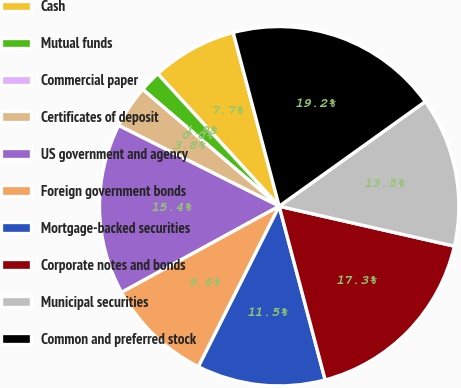Convert chart to OTSL. <chart><loc_0><loc_0><loc_500><loc_500><pie_chart><fcel>Cash<fcel>Mutual funds<fcel>Commercial paper<fcel>Certificates of deposit<fcel>US government and agency<fcel>Foreign government bonds<fcel>Mortgage-backed securities<fcel>Corporate notes and bonds<fcel>Municipal securities<fcel>Common and preferred stock<nl><fcel>7.69%<fcel>1.92%<fcel>0.0%<fcel>3.85%<fcel>15.38%<fcel>9.62%<fcel>11.54%<fcel>17.31%<fcel>13.46%<fcel>19.23%<nl></chart> 